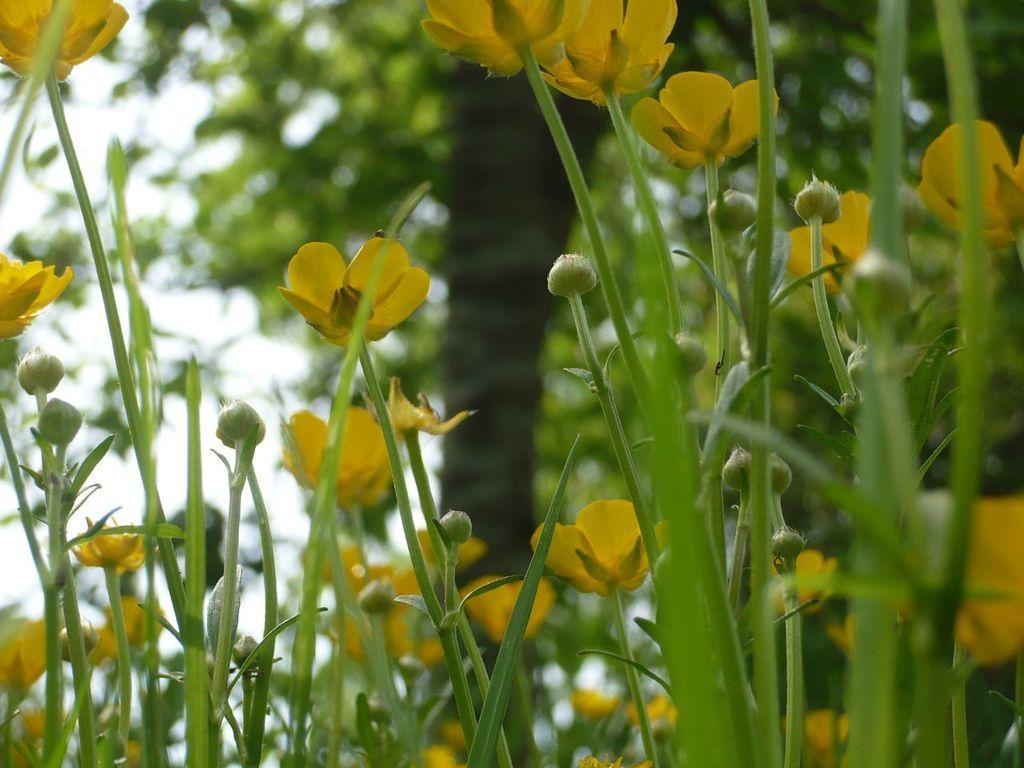How would you summarize this image in a sentence or two? This image consists of yellow flowers. At the bottom, there are small plants. In the background, there is a tree. 